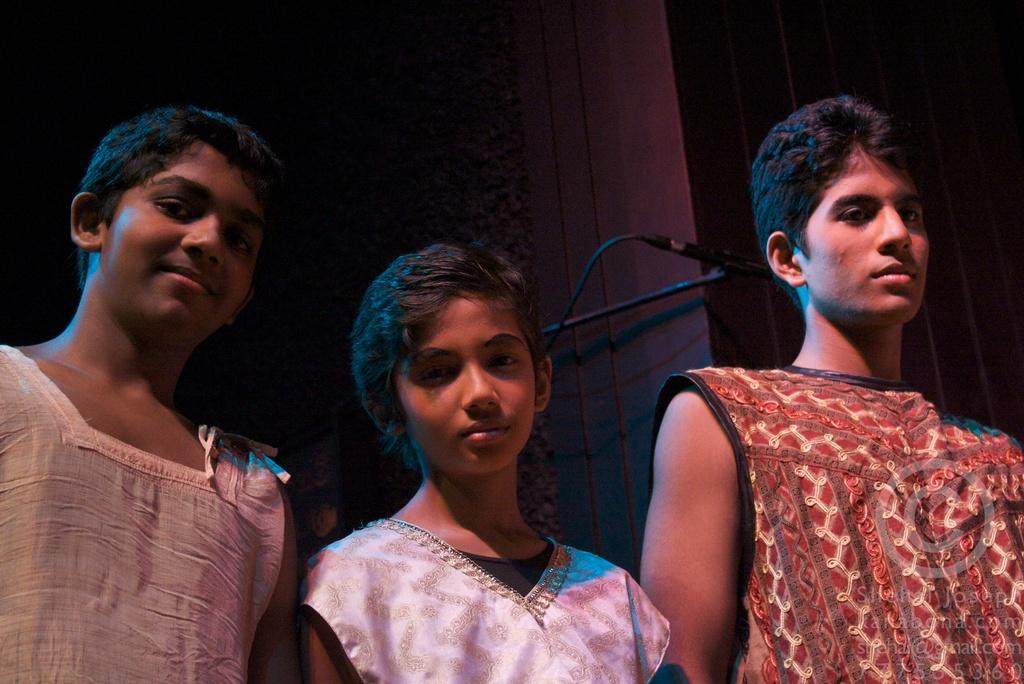How many people are in the image? There are three persons standing in the image. What are the persons doing in the image? The persons are watching something. Can you describe any objects visible in the image? Yes, there is a microphone visible in the image. What can be seen in the background of the image? There is a wall in the background of the image. What type of fowl can be seen in the image? There is no fowl present in the image. How does the dad in the image react to the winter season? There is no dad mentioned in the image, nor is there any reference to a winter season. 